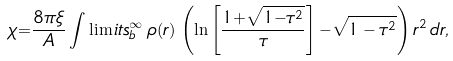<formula> <loc_0><loc_0><loc_500><loc_500>\chi { = } \frac { 8 \pi \xi } { A } \int \lim i t s _ { b } ^ { \infty } \, \rho ( r ) \, \left ( \ln \left [ \frac { 1 { + } \sqrt { 1 { - } \tau ^ { 2 } } } { \tau } \right ] { - } \sqrt { 1 - \tau ^ { 2 } } \right ) r ^ { 2 } \, d r ,</formula> 